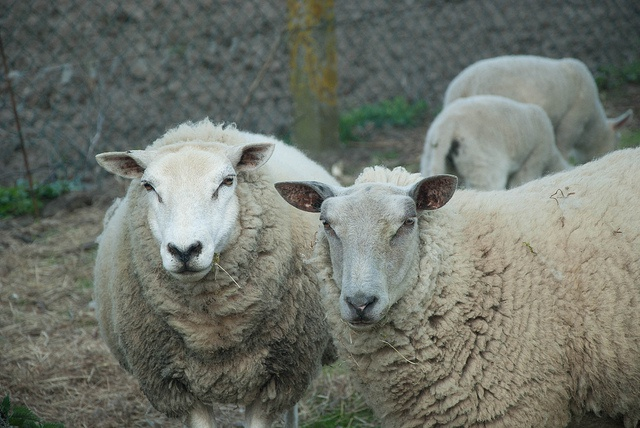Describe the objects in this image and their specific colors. I can see sheep in black, darkgray, and gray tones, sheep in black, gray, darkgray, and lightgray tones, sheep in black, darkgray, and gray tones, and sheep in black, darkgray, and gray tones in this image. 